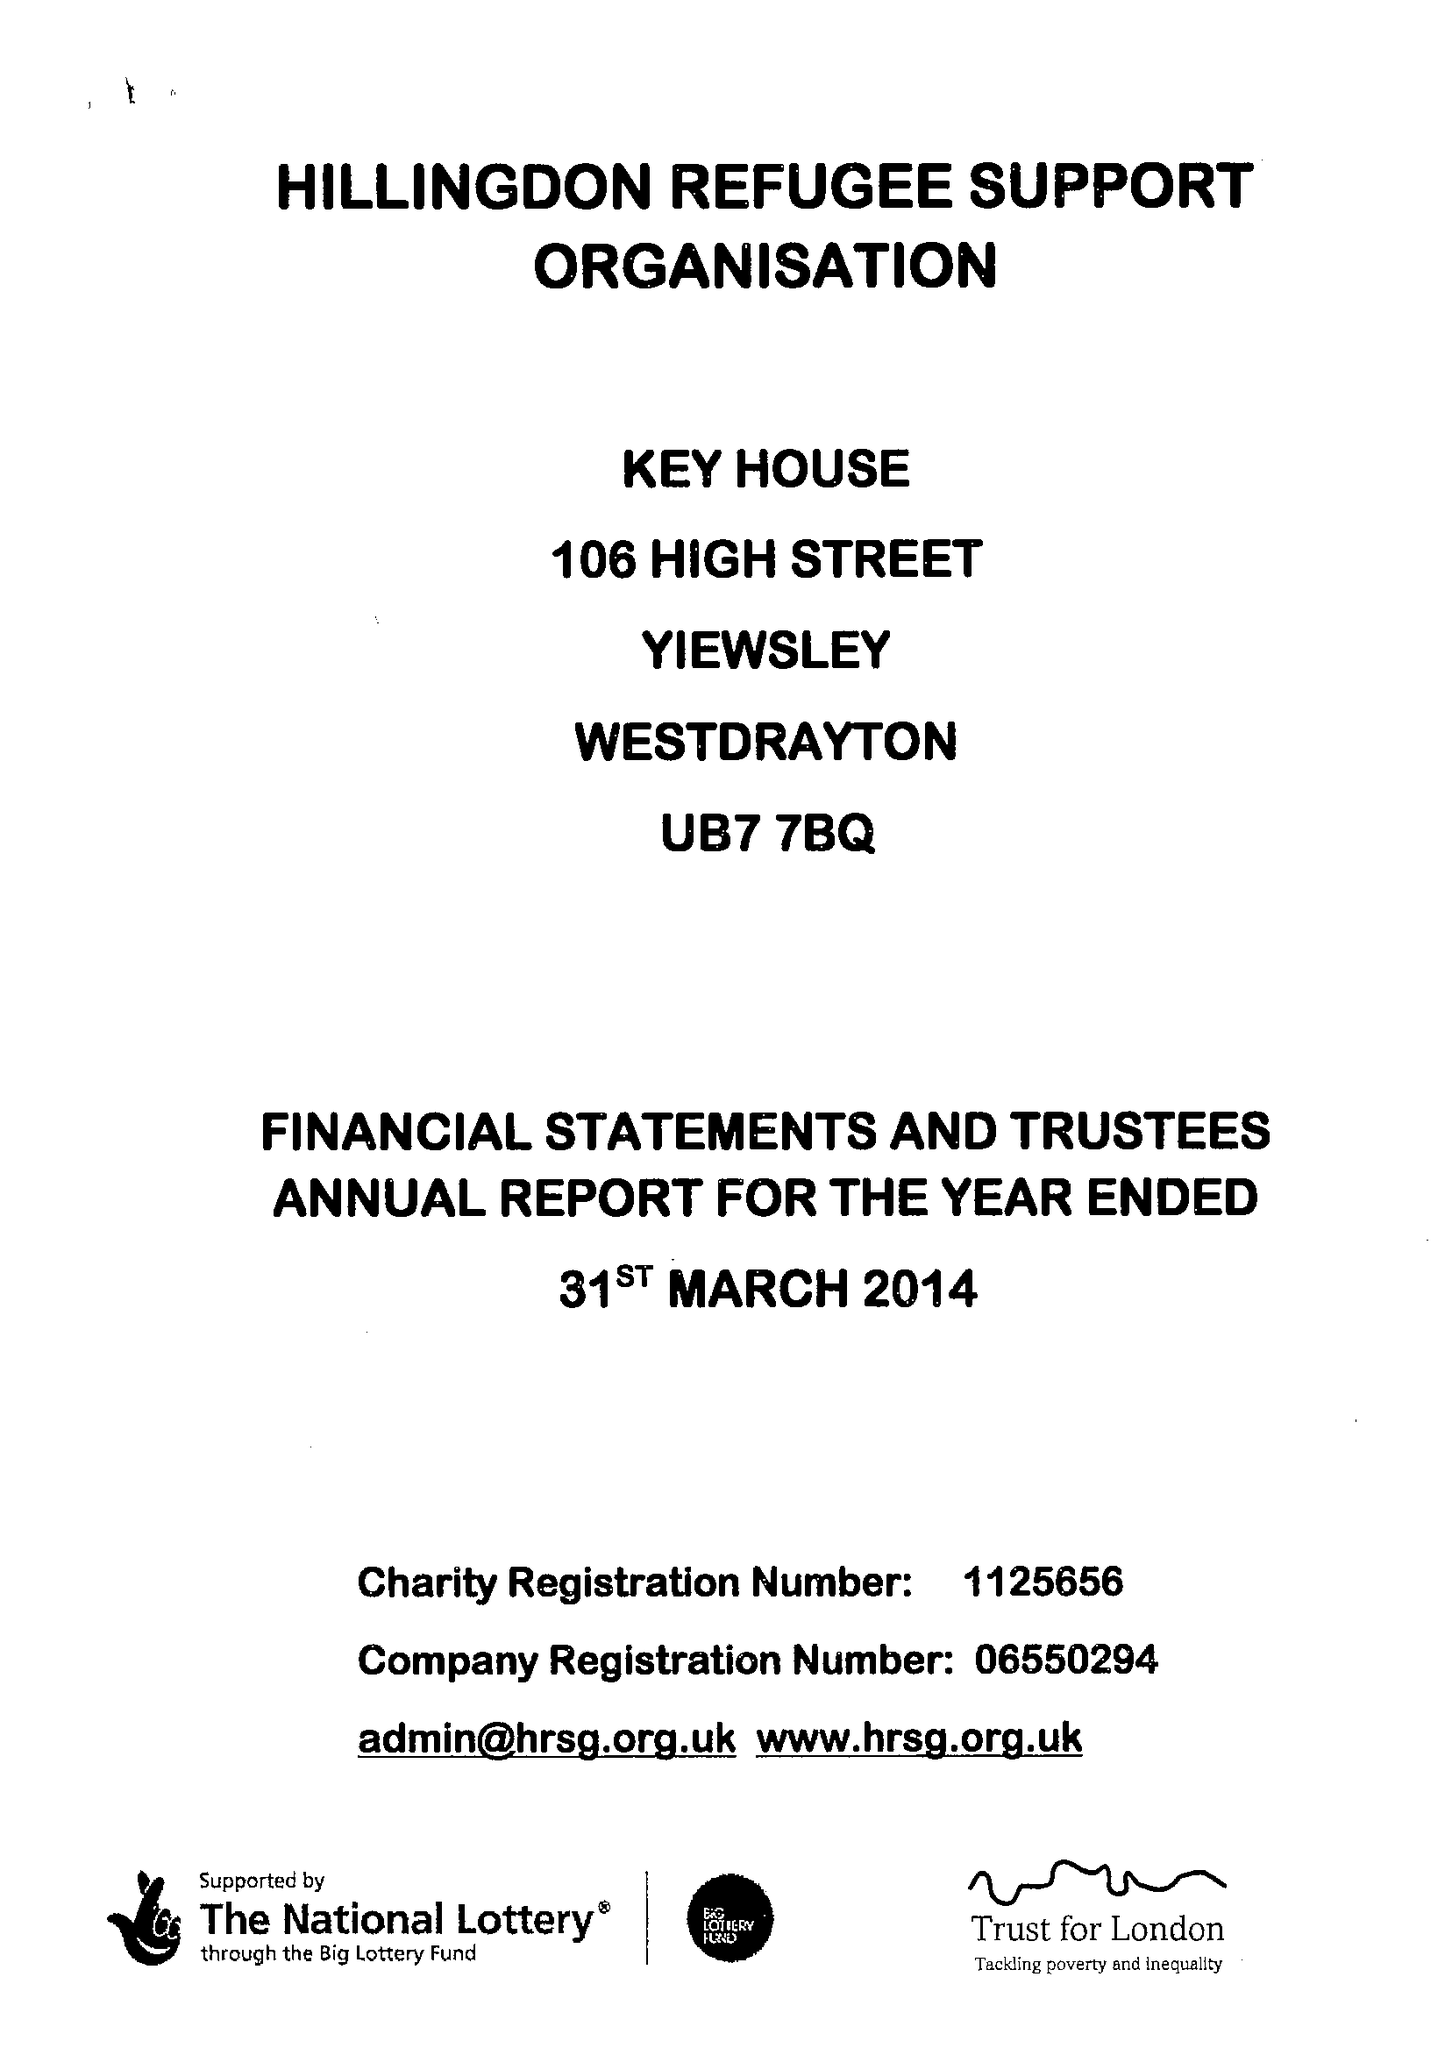What is the value for the address__post_town?
Answer the question using a single word or phrase. WEST DRAYTON 